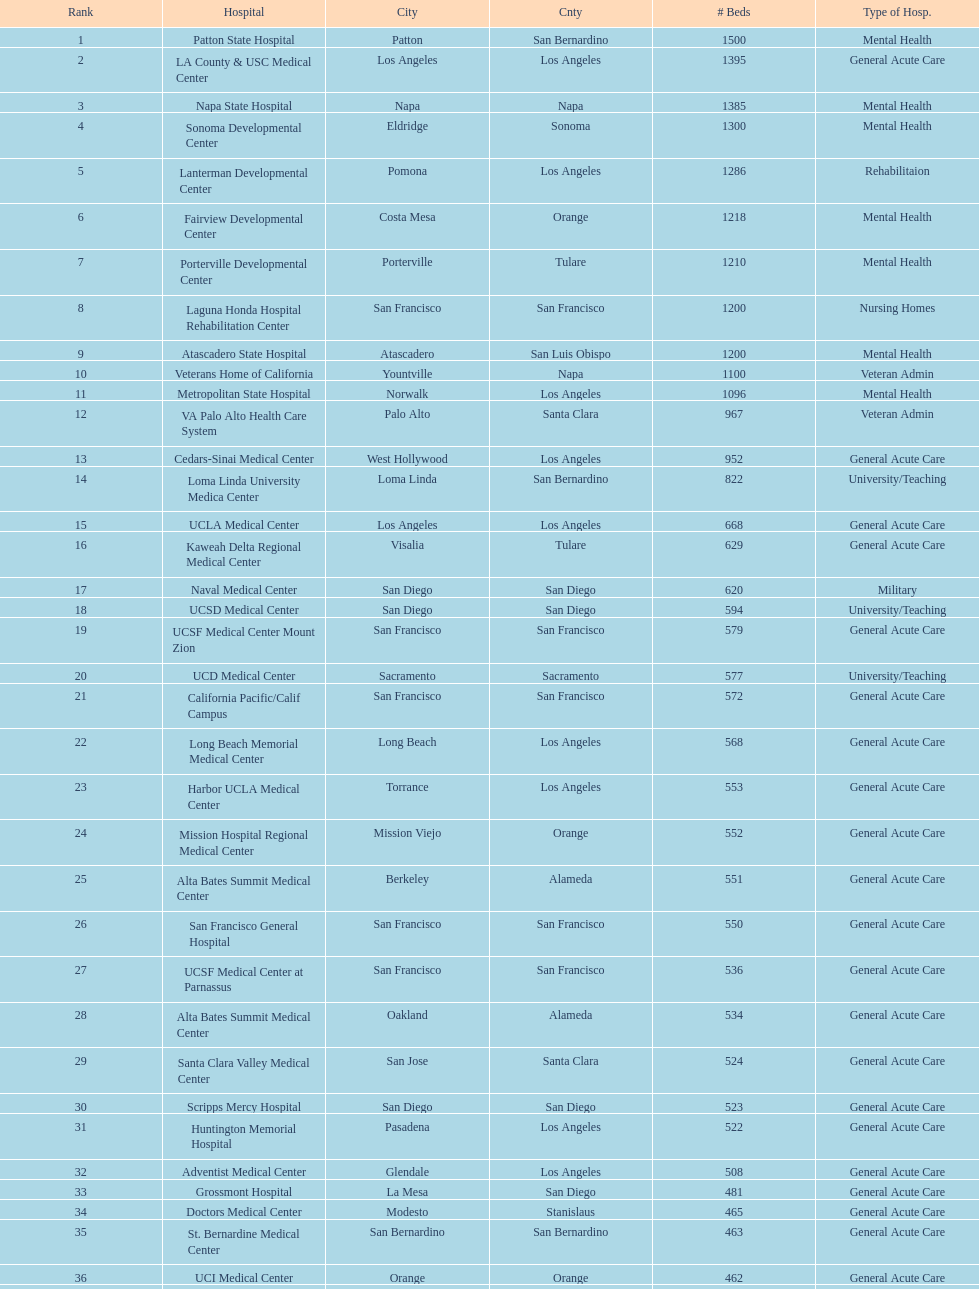Which type of hospitals are the same as grossmont hospital? General Acute Care. 